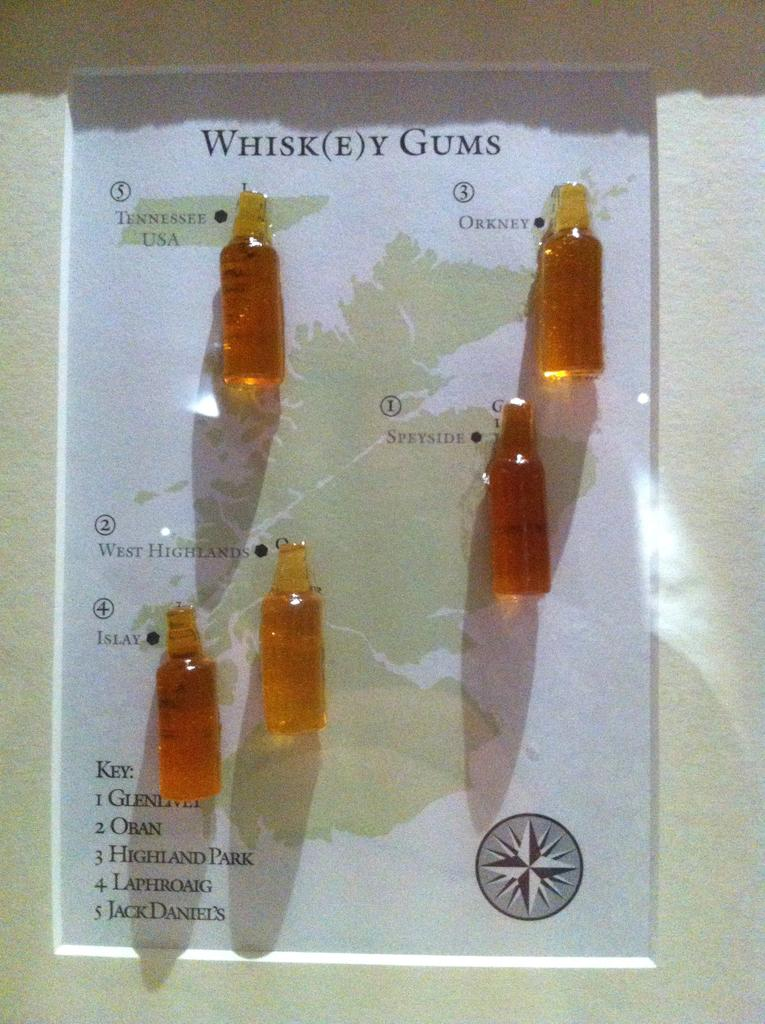<image>
Present a compact description of the photo's key features. a poster on a wall with five small whiskey gums bottles on it 